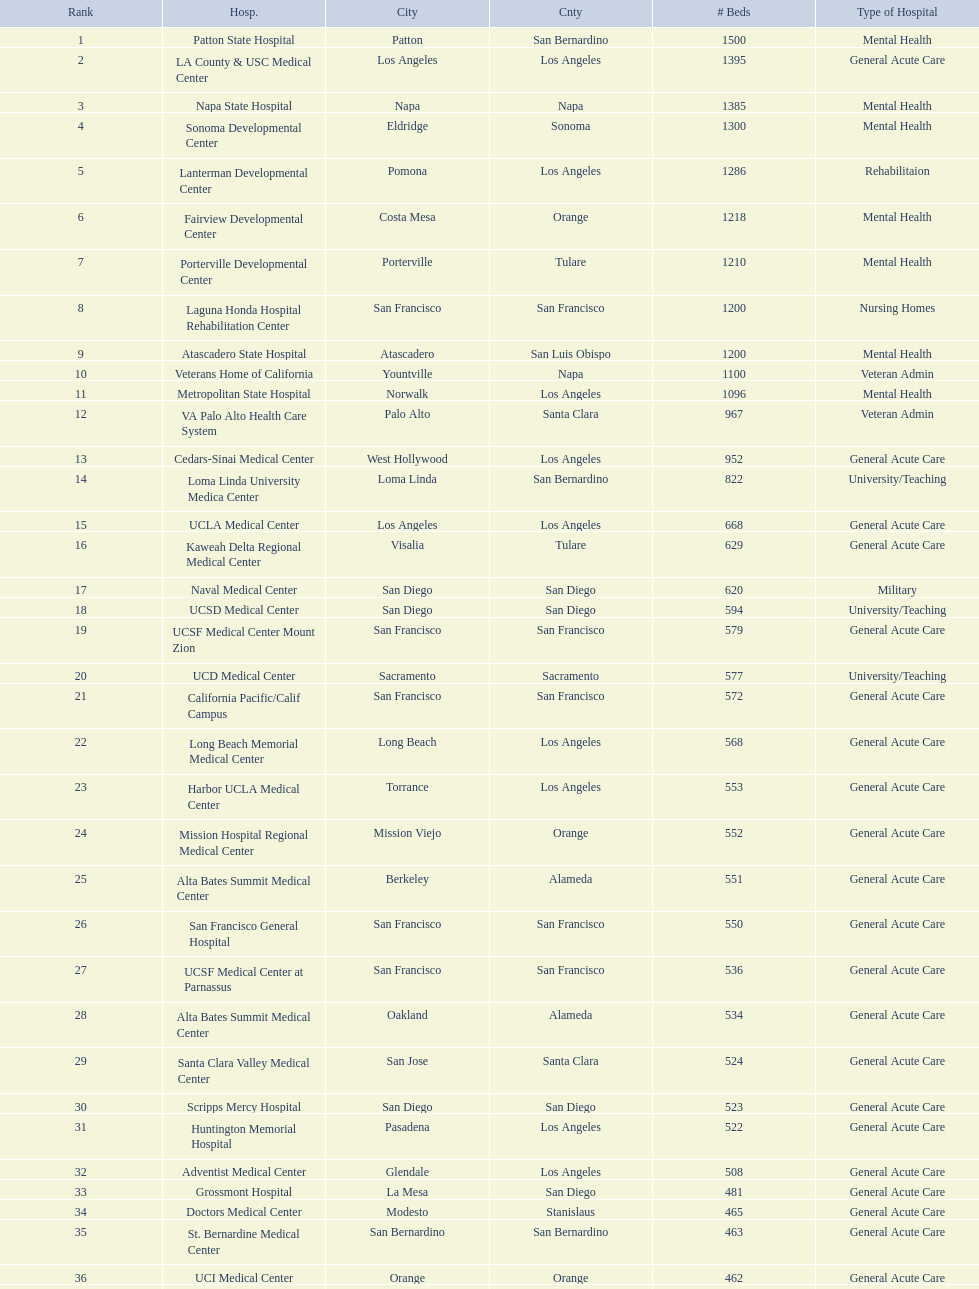Does patton state hospital in the city of patton in san bernardino county have more mental health hospital beds than atascadero state hospital in atascadero, san luis obispo county? Yes. 